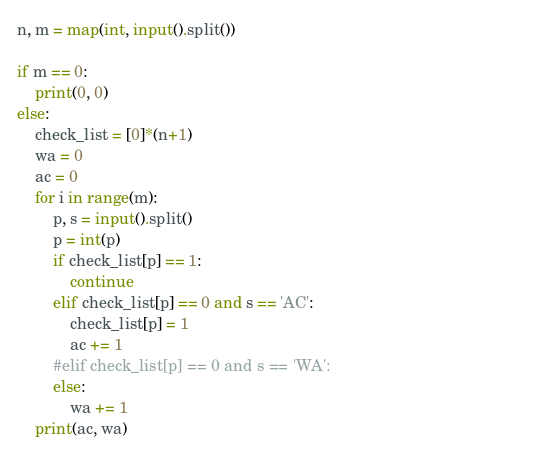Convert code to text. <code><loc_0><loc_0><loc_500><loc_500><_Python_>n, m = map(int, input().split())

if m == 0:
    print(0, 0)
else:
    check_list = [0]*(n+1)
    wa = 0
    ac = 0
    for i in range(m):
        p, s = input().split()
        p = int(p)
        if check_list[p] == 1:
            continue
        elif check_list[p] == 0 and s == 'AC':
            check_list[p] = 1
            ac += 1
        #elif check_list[p] == 0 and s == 'WA':                                          
        else:
            wa += 1
    print(ac, wa)</code> 